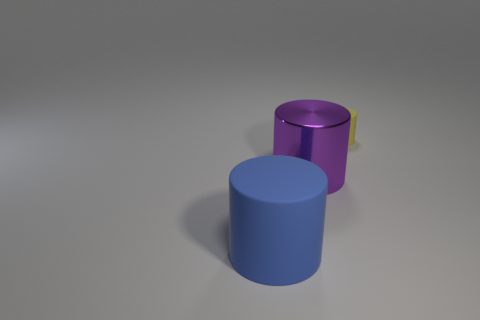Add 3 yellow cylinders. How many objects exist? 6 Subtract all large blue cylinders. How many cylinders are left? 2 Add 3 big blue matte cylinders. How many big blue matte cylinders are left? 4 Add 1 rubber cylinders. How many rubber cylinders exist? 3 Subtract 0 purple blocks. How many objects are left? 3 Subtract all gray cylinders. Subtract all blue blocks. How many cylinders are left? 3 Subtract all green matte blocks. Subtract all shiny cylinders. How many objects are left? 2 